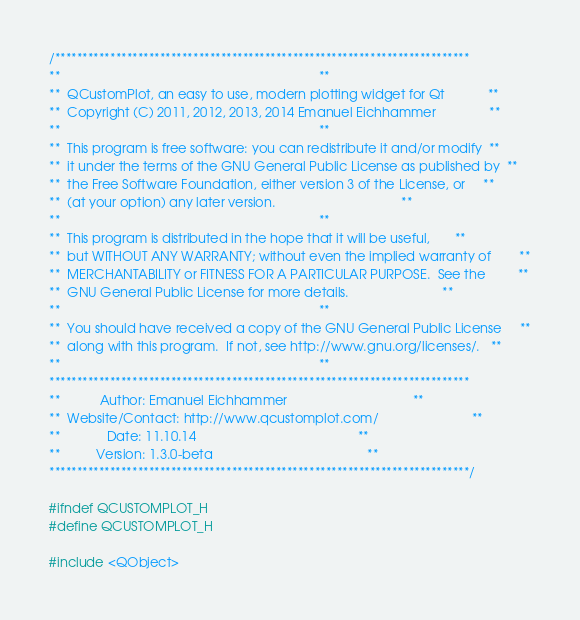<code> <loc_0><loc_0><loc_500><loc_500><_C_>/***************************************************************************
**                                                                        **
**  QCustomPlot, an easy to use, modern plotting widget for Qt            **
**  Copyright (C) 2011, 2012, 2013, 2014 Emanuel Eichhammer               **
**                                                                        **
**  This program is free software: you can redistribute it and/or modify  **
**  it under the terms of the GNU General Public License as published by  **
**  the Free Software Foundation, either version 3 of the License, or     **
**  (at your option) any later version.                                   **
**                                                                        **
**  This program is distributed in the hope that it will be useful,       **
**  but WITHOUT ANY WARRANTY; without even the implied warranty of        **
**  MERCHANTABILITY or FITNESS FOR A PARTICULAR PURPOSE.  See the         **
**  GNU General Public License for more details.                          **
**                                                                        **
**  You should have received a copy of the GNU General Public License     **
**  along with this program.  If not, see http://www.gnu.org/licenses/.   **
**                                                                        **
****************************************************************************
**           Author: Emanuel Eichhammer                                   **
**  Website/Contact: http://www.qcustomplot.com/                          **
**             Date: 11.10.14                                             **
**          Version: 1.3.0-beta                                           **
****************************************************************************/

#ifndef QCUSTOMPLOT_H
#define QCUSTOMPLOT_H

#include <QObject></code> 